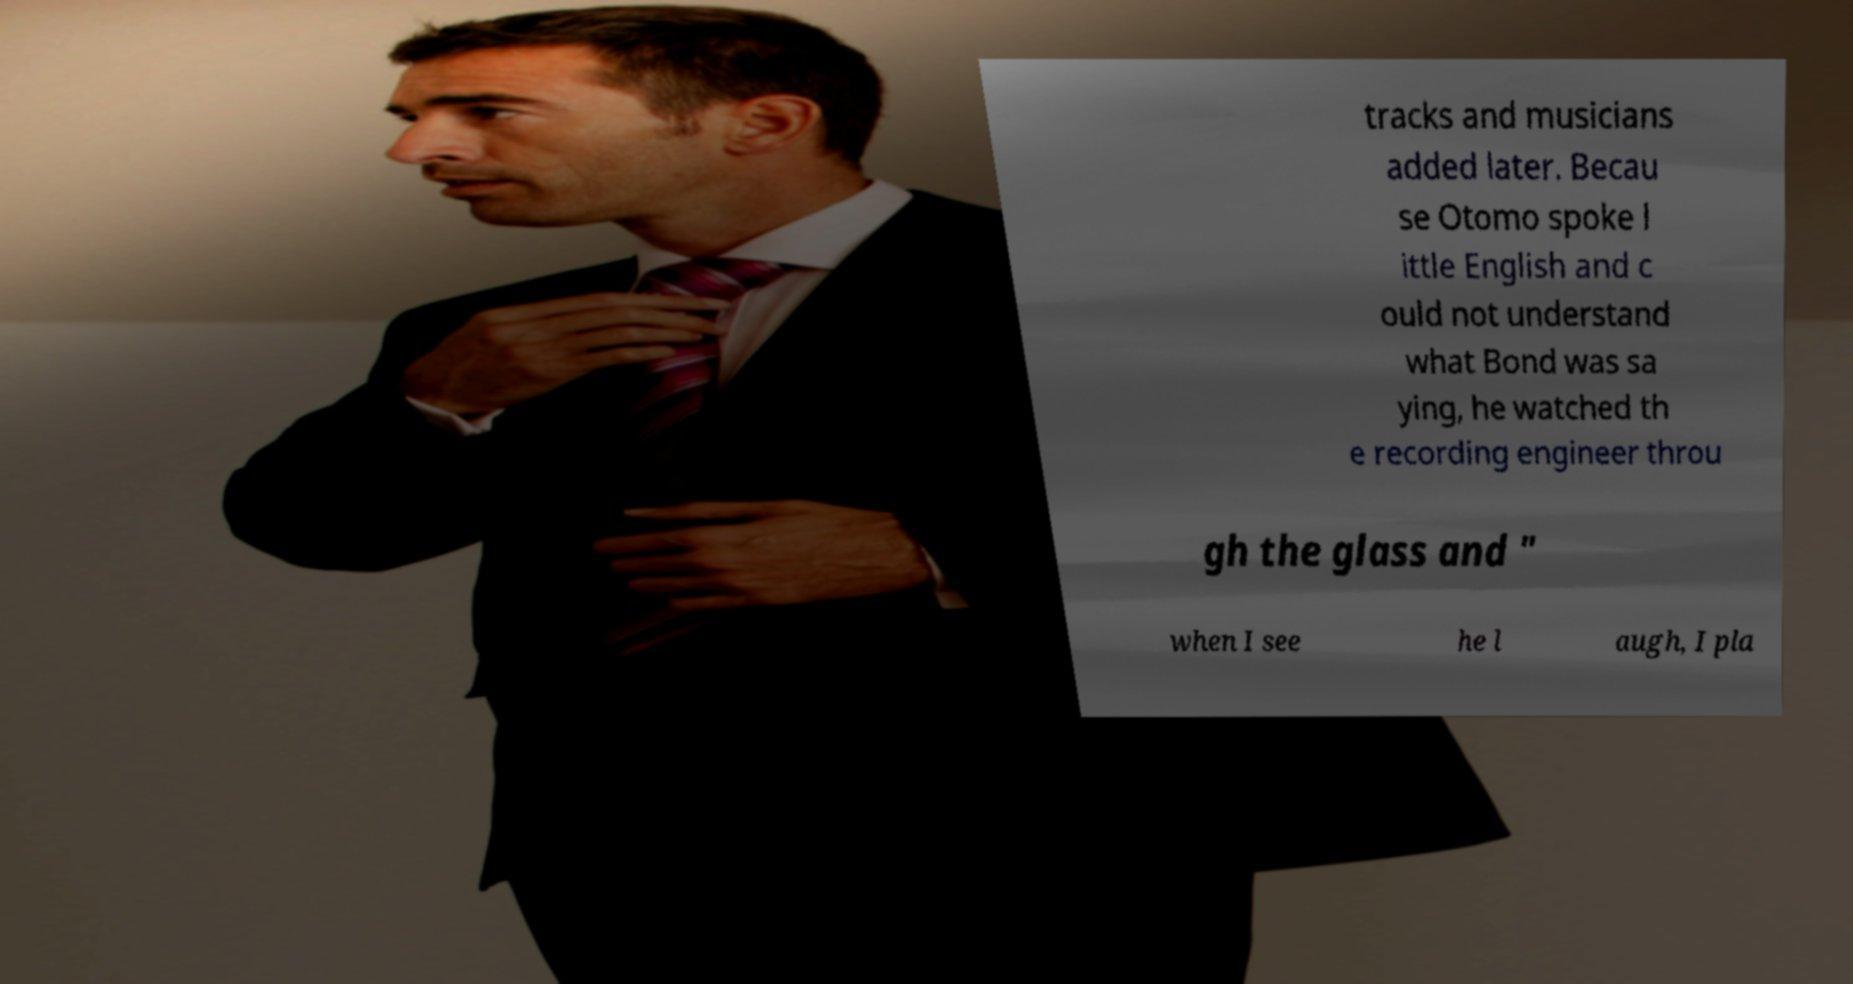Can you accurately transcribe the text from the provided image for me? tracks and musicians added later. Becau se Otomo spoke l ittle English and c ould not understand what Bond was sa ying, he watched th e recording engineer throu gh the glass and " when I see he l augh, I pla 